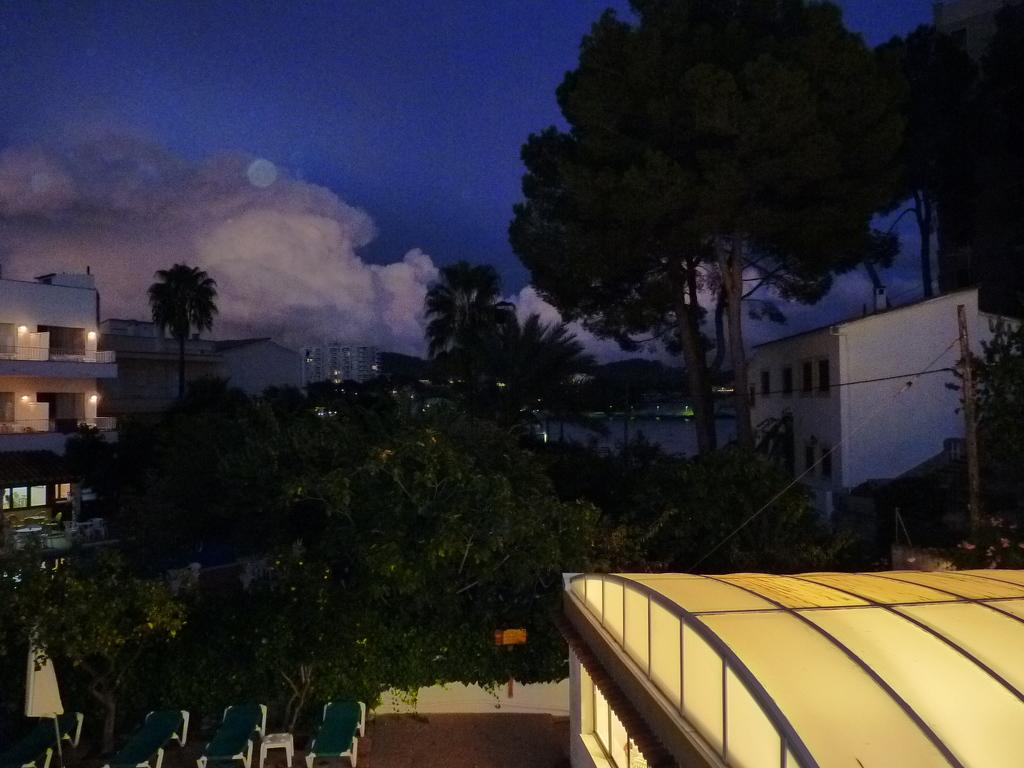What is located in the foreground of the image? There are plants and chairs in the foreground. What structure can be seen above the plants and chairs in the foreground? There is a roof visible in the foreground. What can be seen in the background of the image? There are buildings, trees, and the moon visible in the background. What language is spoken by the plants in the foreground? Plants do not speak any language, so this question cannot be answered. 